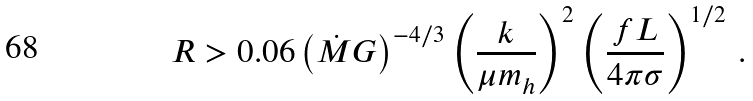Convert formula to latex. <formula><loc_0><loc_0><loc_500><loc_500>R > 0 . 0 6 \left ( \dot { M } G \right ) ^ { - 4 / 3 } \left ( \frac { k } { \mu m _ { h } } \right ) ^ { 2 } \left ( \frac { f L } { 4 \pi \sigma } \right ) ^ { 1 / 2 } \, .</formula> 